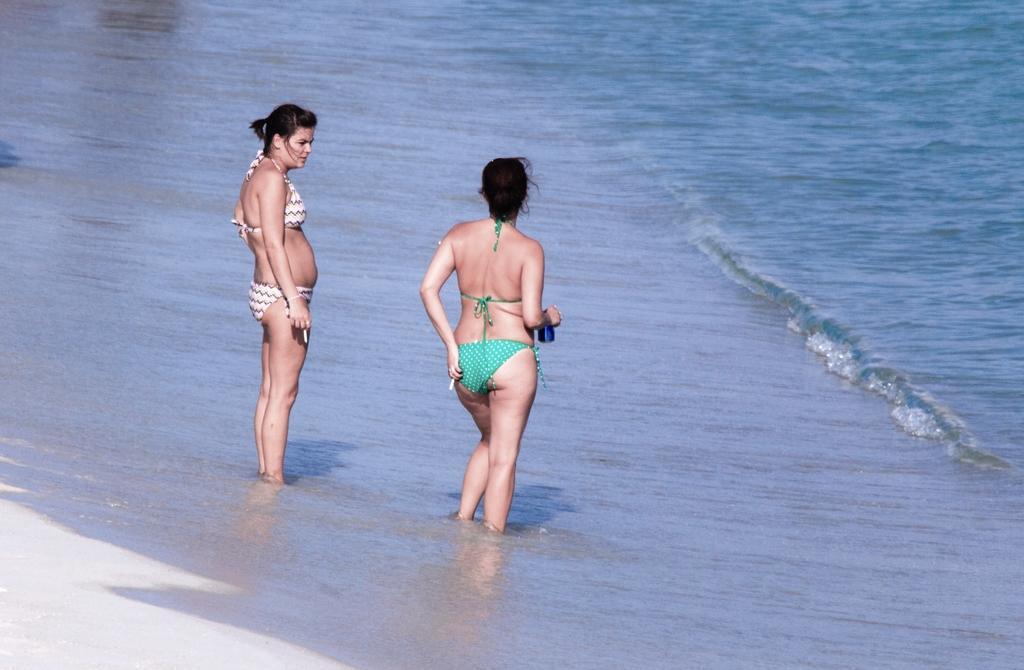Describe this image in one or two sentences. In this image, we can see two persons wearing clothes and standing in the beach. 